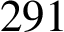<formula> <loc_0><loc_0><loc_500><loc_500>2 9 1</formula> 